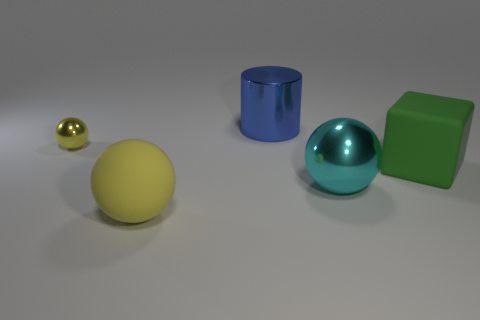Subtract all red cylinders. How many yellow spheres are left? 2 Subtract all yellow balls. How many balls are left? 1 Add 3 small blue rubber cylinders. How many objects exist? 8 Subtract 1 spheres. How many spheres are left? 2 Subtract all spheres. How many objects are left? 2 Subtract all purple spheres. Subtract all brown cylinders. How many spheres are left? 3 Add 5 large cubes. How many large cubes are left? 6 Add 2 gray matte objects. How many gray matte objects exist? 2 Subtract 0 gray balls. How many objects are left? 5 Subtract all big cyan spheres. Subtract all cyan balls. How many objects are left? 3 